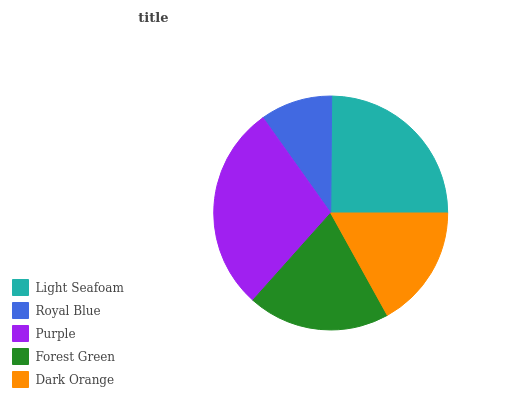Is Royal Blue the minimum?
Answer yes or no. Yes. Is Purple the maximum?
Answer yes or no. Yes. Is Purple the minimum?
Answer yes or no. No. Is Royal Blue the maximum?
Answer yes or no. No. Is Purple greater than Royal Blue?
Answer yes or no. Yes. Is Royal Blue less than Purple?
Answer yes or no. Yes. Is Royal Blue greater than Purple?
Answer yes or no. No. Is Purple less than Royal Blue?
Answer yes or no. No. Is Forest Green the high median?
Answer yes or no. Yes. Is Forest Green the low median?
Answer yes or no. Yes. Is Purple the high median?
Answer yes or no. No. Is Dark Orange the low median?
Answer yes or no. No. 